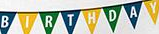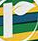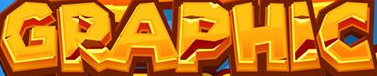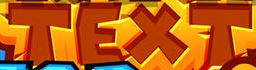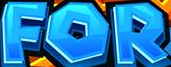Read the text content from these images in order, separated by a semicolon. BIRTHDAY; r; GRAPHIC; TEXT; FOR 